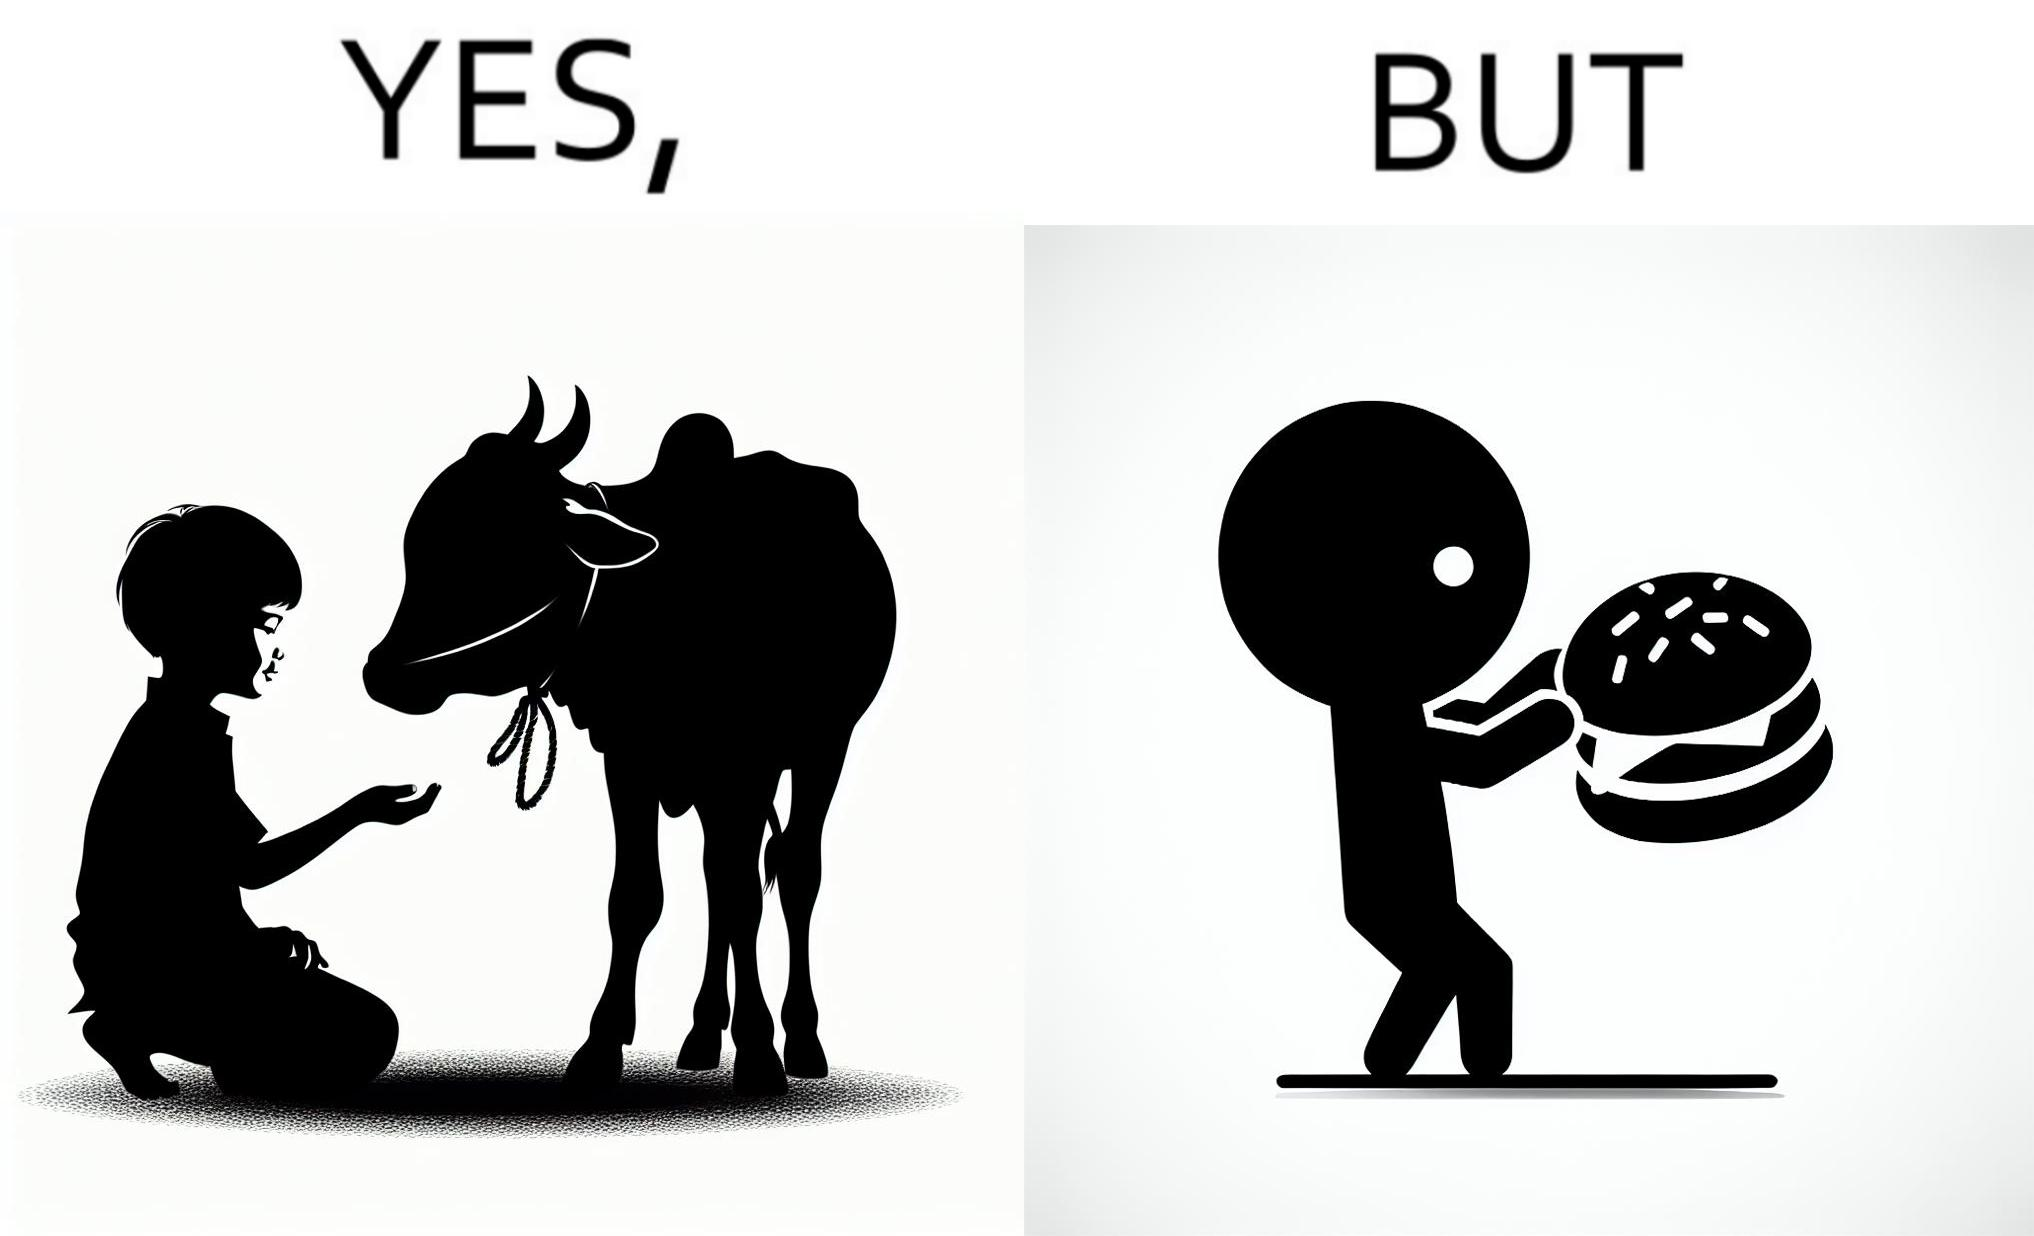Explain why this image is satirical. The irony is that the boy is petting the cow to show that he cares about the animal, but then he also eats hamburgers made from the same cows 